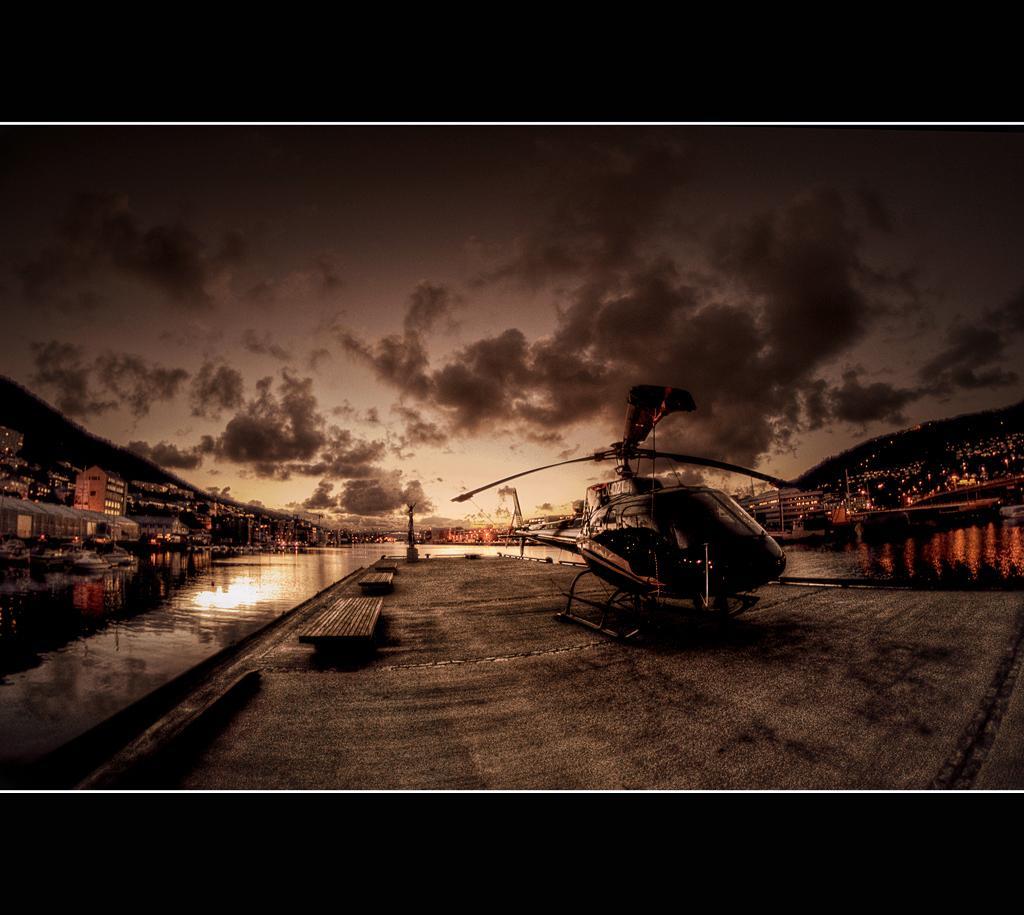Can you describe this image briefly? In this image we can see a helicopter, there are benches, houses, also we can see the mountains, water, and the sky, the borders are black in color. 